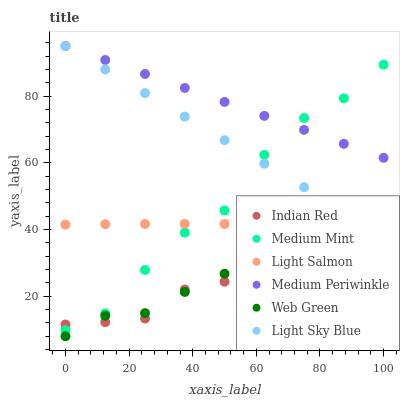Does Indian Red have the minimum area under the curve?
Answer yes or no. Yes. Does Medium Periwinkle have the maximum area under the curve?
Answer yes or no. Yes. Does Light Salmon have the minimum area under the curve?
Answer yes or no. No. Does Light Salmon have the maximum area under the curve?
Answer yes or no. No. Is Light Sky Blue the smoothest?
Answer yes or no. Yes. Is Medium Mint the roughest?
Answer yes or no. Yes. Is Light Salmon the smoothest?
Answer yes or no. No. Is Light Salmon the roughest?
Answer yes or no. No. Does Web Green have the lowest value?
Answer yes or no. Yes. Does Light Salmon have the lowest value?
Answer yes or no. No. Does Light Sky Blue have the highest value?
Answer yes or no. Yes. Does Light Salmon have the highest value?
Answer yes or no. No. Is Indian Red less than Light Sky Blue?
Answer yes or no. Yes. Is Light Salmon greater than Indian Red?
Answer yes or no. Yes. Does Web Green intersect Indian Red?
Answer yes or no. Yes. Is Web Green less than Indian Red?
Answer yes or no. No. Is Web Green greater than Indian Red?
Answer yes or no. No. Does Indian Red intersect Light Sky Blue?
Answer yes or no. No. 